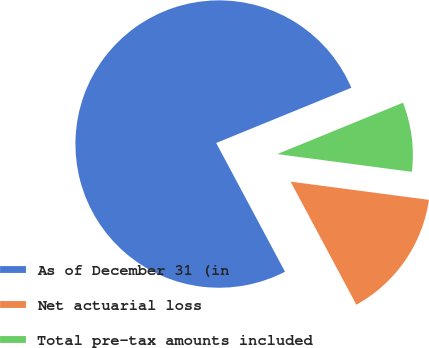Convert chart. <chart><loc_0><loc_0><loc_500><loc_500><pie_chart><fcel>As of December 31 (in<fcel>Net actuarial loss<fcel>Total pre-tax amounts included<nl><fcel>76.63%<fcel>15.1%<fcel>8.26%<nl></chart> 